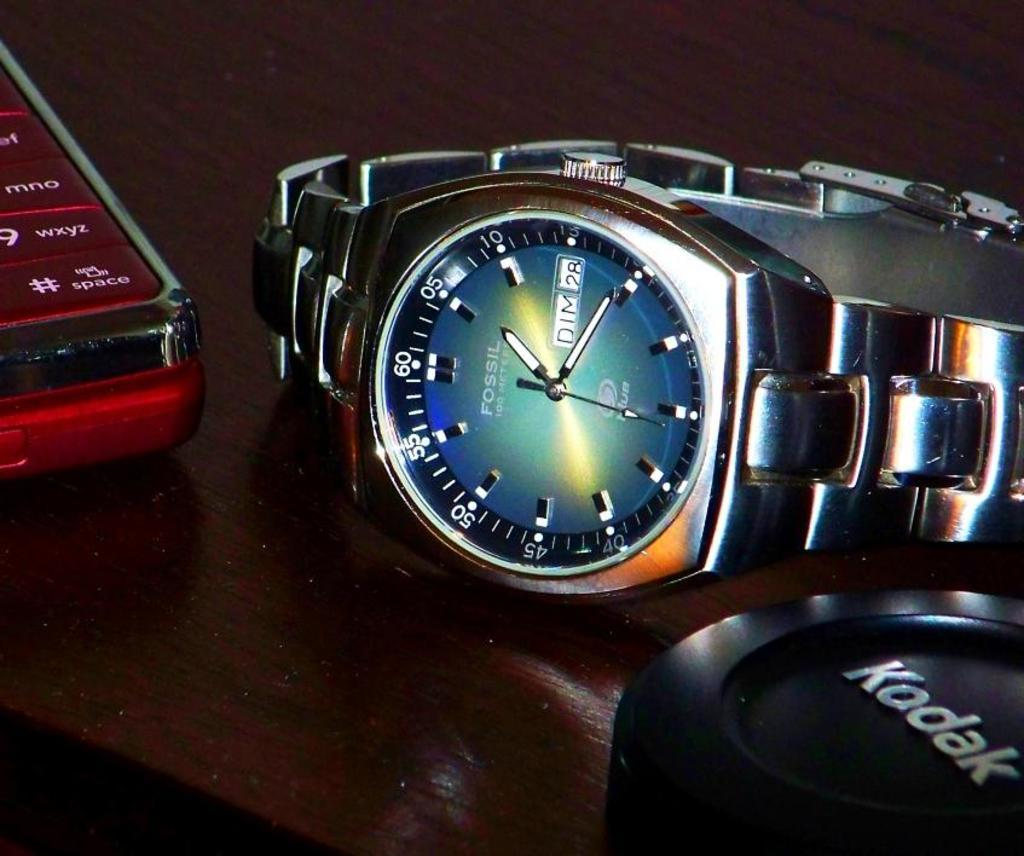<image>
Provide a brief description of the given image. The silver watch is from the company Fossil 